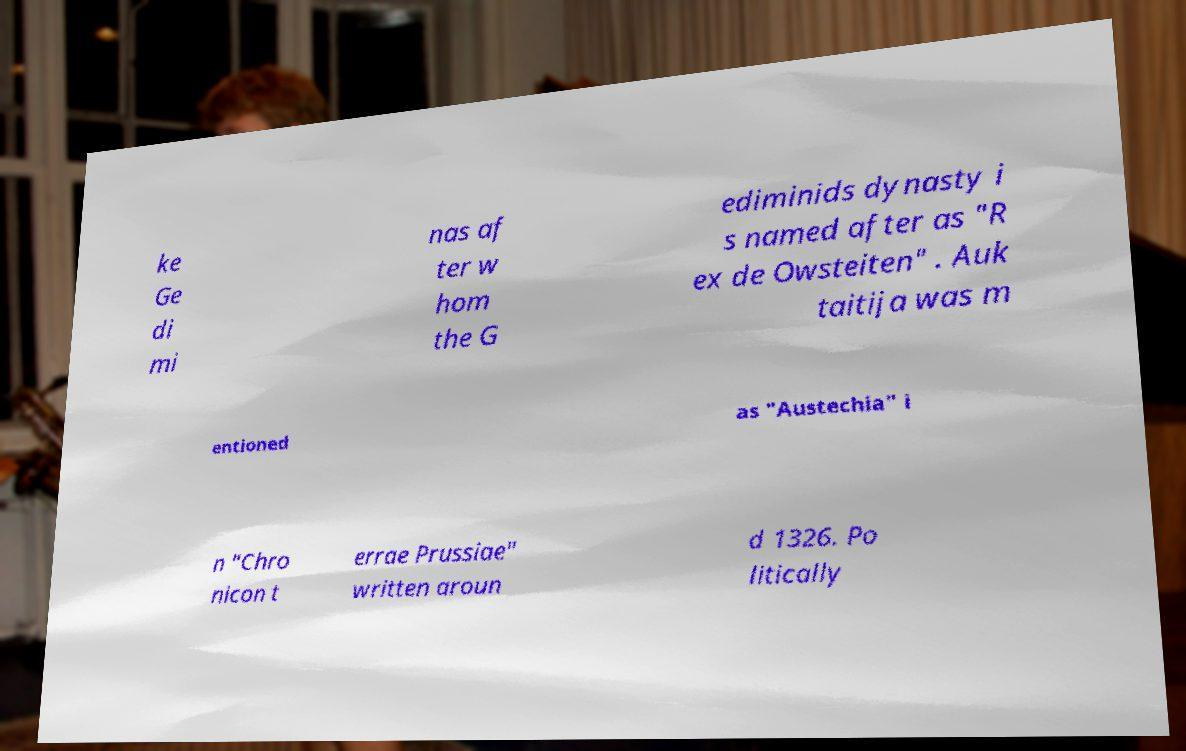What messages or text are displayed in this image? I need them in a readable, typed format. ke Ge di mi nas af ter w hom the G ediminids dynasty i s named after as "R ex de Owsteiten" . Auk taitija was m entioned as "Austechia" i n "Chro nicon t errae Prussiae" written aroun d 1326. Po litically 